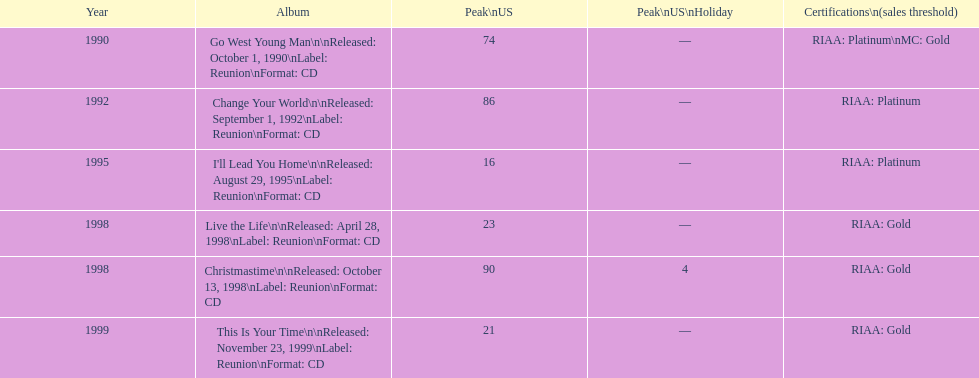Riaa: gold is merely one of the certifications, but what is an alternative? Platinum. 